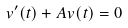Convert formula to latex. <formula><loc_0><loc_0><loc_500><loc_500>v ^ { \prime } ( t ) + A v ( t ) = 0</formula> 